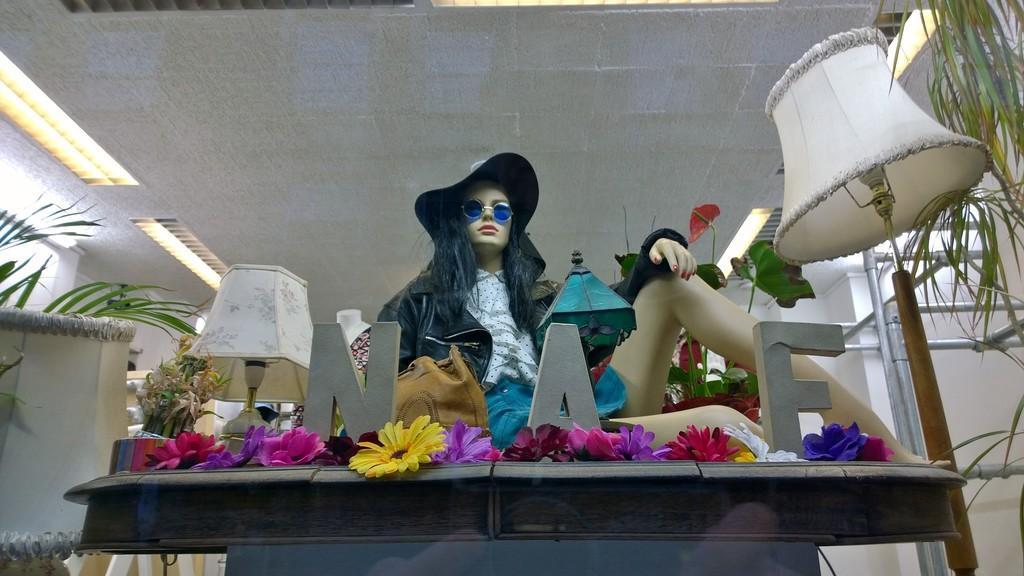Describe this image in one or two sentences. In this image I can see a mannequin which is cream in color wearing white shirt, black jacket and blue skirt and I can see few flowers which are pink, violet, yellow and brown in color. I can see two lamps, few plants and in the background I can see the white colored ceiling and few lights. 